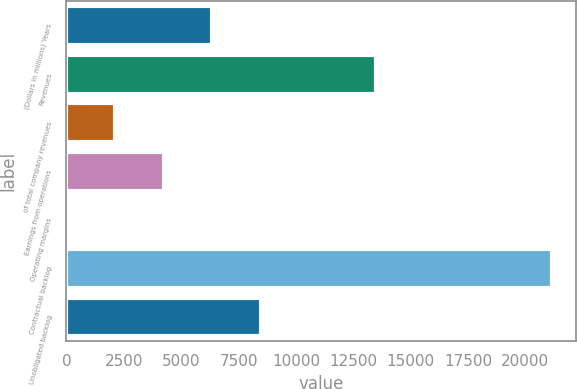<chart> <loc_0><loc_0><loc_500><loc_500><bar_chart><fcel>(Dollars in millions) Years<fcel>Revenues<fcel>of total company revenues<fcel>Earnings from operations<fcel>Operating margins<fcel>Contractual backlog<fcel>Unobligated backlog<nl><fcel>6349.69<fcel>13511<fcel>2123.03<fcel>4236.36<fcel>9.7<fcel>21143<fcel>8463.02<nl></chart> 